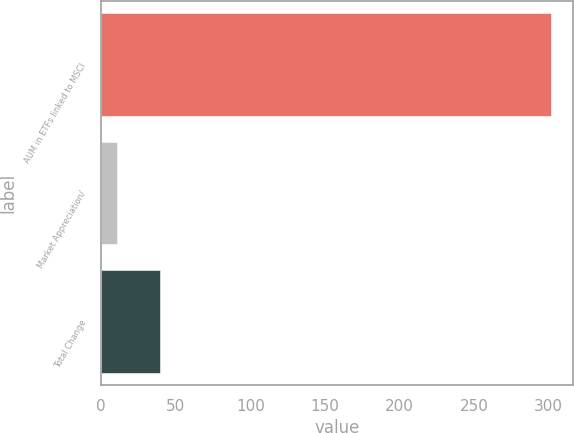Convert chart to OTSL. <chart><loc_0><loc_0><loc_500><loc_500><bar_chart><fcel>AUM in ETFs linked to MSCI<fcel>Market Appreciation/<fcel>Total Change<nl><fcel>301.6<fcel>10.5<fcel>39.61<nl></chart> 